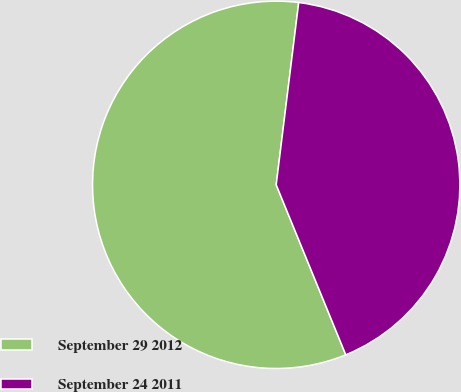Convert chart. <chart><loc_0><loc_0><loc_500><loc_500><pie_chart><fcel>September 29 2012<fcel>September 24 2011<nl><fcel>58.14%<fcel>41.86%<nl></chart> 